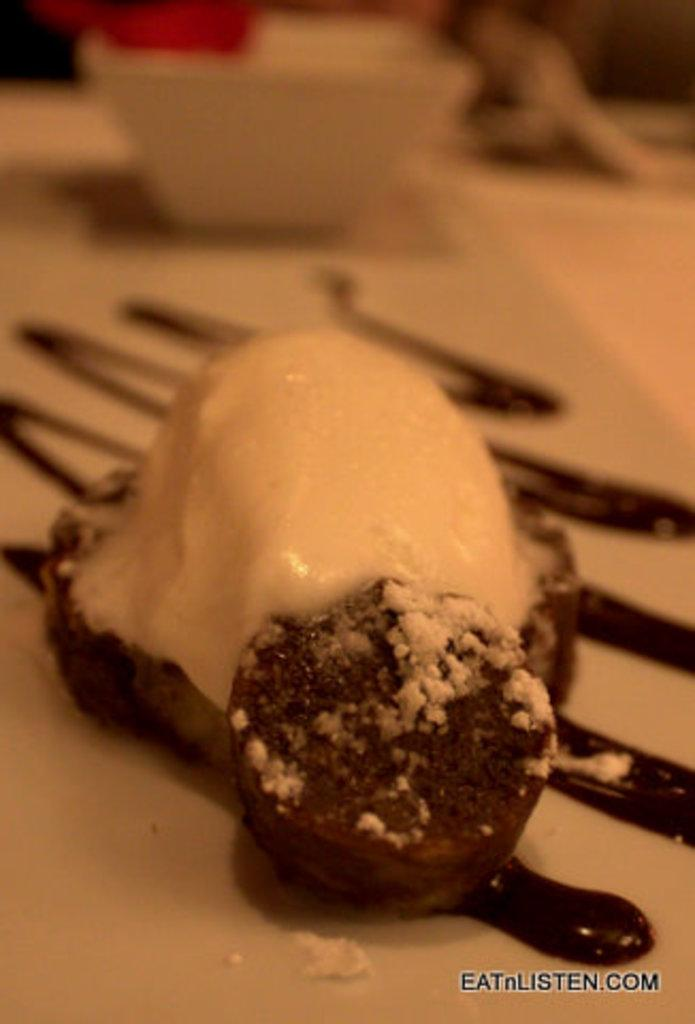What is on the plate in the image? There is food on a plate in the image. What else can be seen in the image besides the plate? There are bowls visible in the image. Where is the text located in the image? The text is at the bottom right of the image. What type of straw is being used by the turkey in the image? There is no turkey or straw present in the image. 